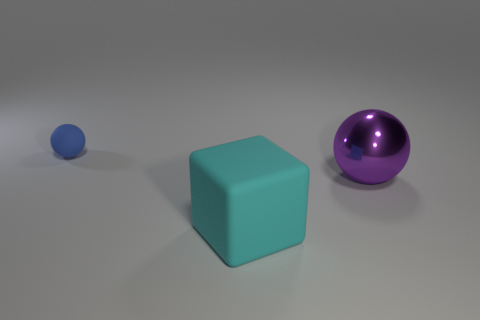What color is the big thing to the left of the sphere that is to the right of the blue ball?
Your answer should be very brief. Cyan. There is a metal ball; how many blocks are behind it?
Offer a very short reply. 0. What is the color of the matte ball?
Your answer should be compact. Blue. What number of big things are yellow balls or purple metallic spheres?
Your answer should be compact. 1. There is a object that is behind the purple thing; is it the same color as the sphere that is right of the blue thing?
Provide a short and direct response. No. How many other things are the same color as the matte cube?
Your answer should be compact. 0. There is a matte thing in front of the tiny object; what shape is it?
Your answer should be compact. Cube. Are there fewer gray balls than blue rubber spheres?
Make the answer very short. Yes. Do the object left of the cube and the purple sphere have the same material?
Your response must be concise. No. Is there anything else that has the same size as the rubber block?
Ensure brevity in your answer.  Yes. 